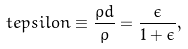Convert formula to latex. <formula><loc_0><loc_0><loc_500><loc_500>\ t e p s i l o n \equiv \frac { \rho d } { \rho } = \frac { \epsilon } { 1 + \epsilon } ,</formula> 